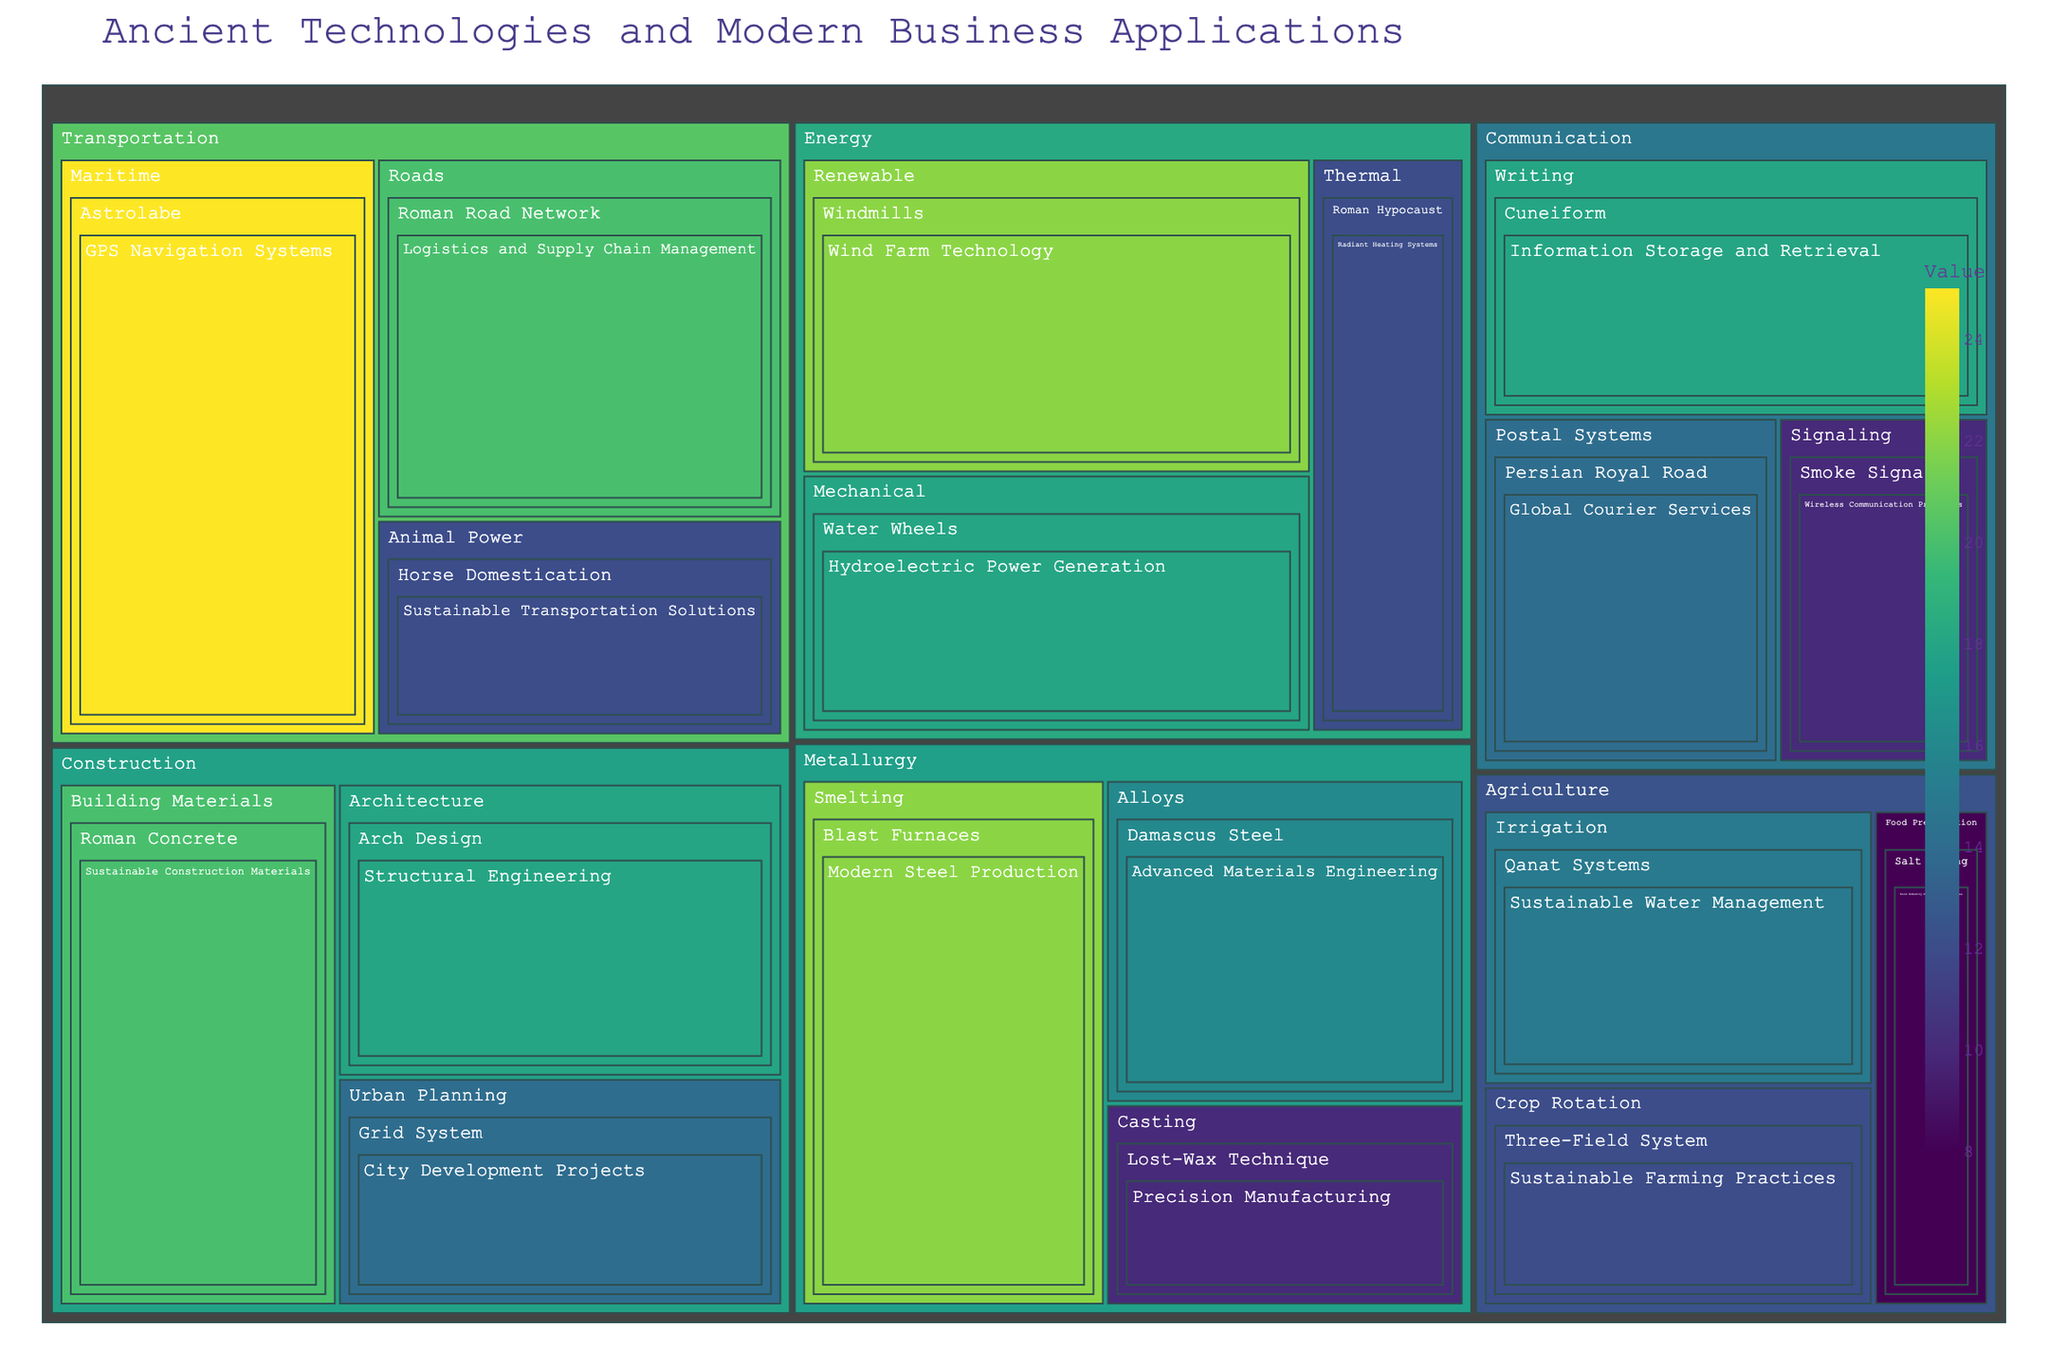What is the title of the treemap? The title of the treemap is displayed at the top of the figure. It summarizes the content and focus of the treemap.
Answer: Ancient Technologies and Modern Business Applications Which category has the highest value total? To determine the category with the highest value total, sum the values of all subcategories within each category and compare them.
Answer: Transportation What is the modern business application associated with 'Qanat Systems'? Identify the technology 'Qanat Systems' in the Agriculture category and its corresponding modern business application.
Answer: Sustainable Water Management How does the value of 'Roman Concrete' compare to 'Cuneiform'? Find the values for 'Roman Concrete' (Construction category) and 'Cuneiform' (Communication category) and compare them.
Answer: Roman Concrete has a higher value What is the total value for all technologies under 'Energy'? Sum the values of all technologies listed under the 'Energy' category: Windmills (22), Water Wheels (18), and Roman Hypocaust (12).
Answer: 52 Which technology in the 'Metallurgy' category has the highest value? Compare the values of all technologies listed under the 'Metallurgy' category to find the one with the highest value.
Answer: Blast Furnaces List all modern business applications under the 'Agriculture' category. Identify all technologies under the 'Agriculture' category and list their corresponding modern business applications.
Answer: Sustainable Water Management, Sustainable Farming Practices, Food Industry Preservation Techniques What is the average value of technologies in 'Communication'? Sum the values of all technologies in the 'Communication' category (18 + 14 + 10) and divide by the number of technologies (3) to find the average.
Answer: 14 Which subcategory within 'Construction' has the lowest total value? Sum the values of technologies within each subcategory of 'Construction' and compare them to find the lowest total.
Answer: Urban Planning How many technologies are there in the entire treemap? Count all unique technologies listed across all categories and subcategories in the treemap.
Answer: 18 